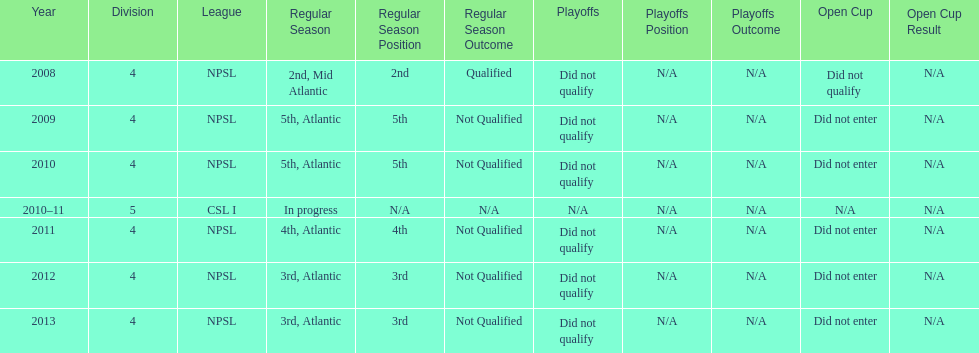For how many years were they unable to qualify for the playoffs? 6. 